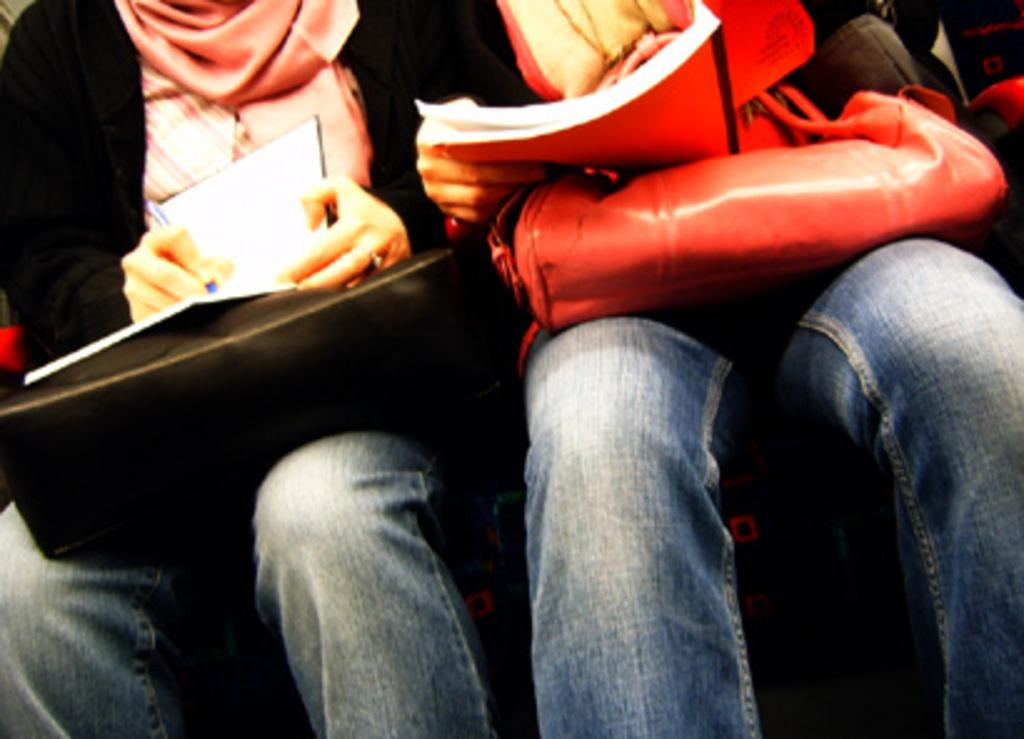How many people are in the image? There are two persons in the image. What are the persons doing in the image? The persons are sitting. What objects are the persons holding in the image? The persons are holding bags and books. Where are the bags and books located in the image? The bags and books are in the middle of the image. What type of punishment is being administered to the persons in the image? There is no indication of punishment in the image; the persons are simply sitting and holding bags and books. Can you tell me how many bikes are visible in the image? There are no bikes present in the image. 